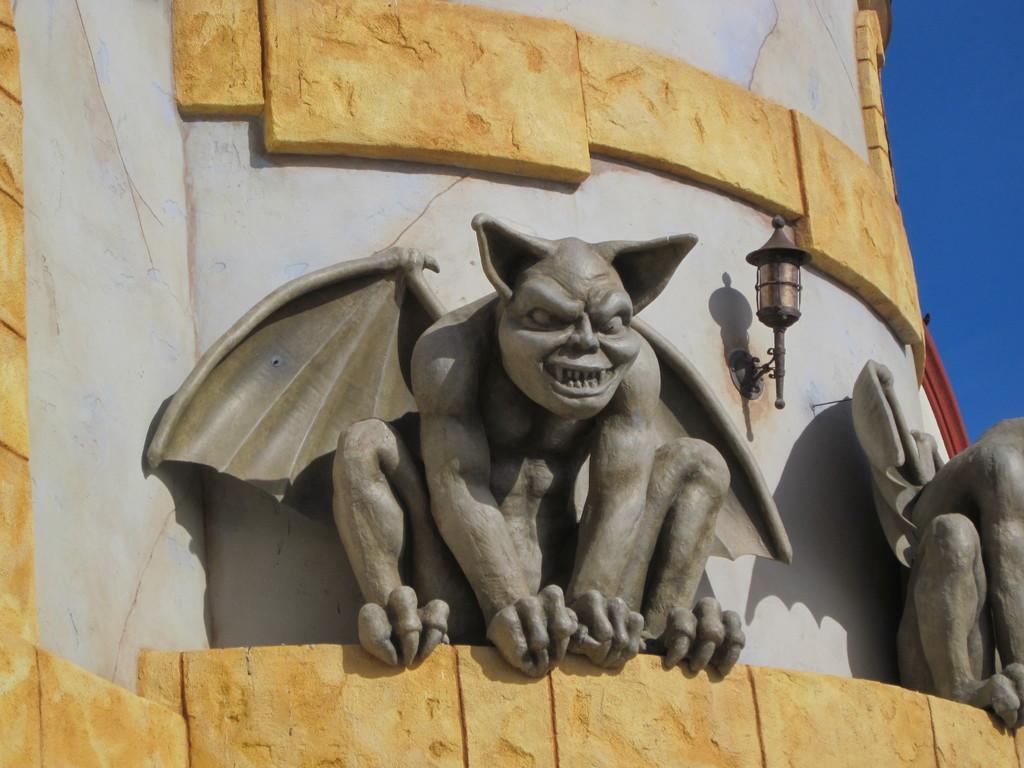Please provide a concise description of this image. In this picture we can see there are sculptures. There is a street lamp attached to the wall of a building. In the top right corner of the image, there is the sky. 